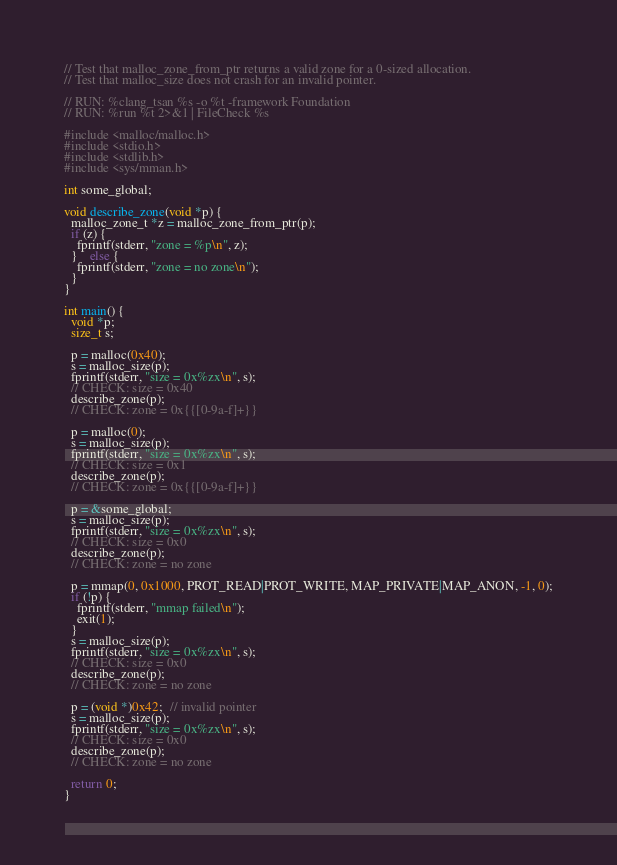<code> <loc_0><loc_0><loc_500><loc_500><_ObjectiveC_>// Test that malloc_zone_from_ptr returns a valid zone for a 0-sized allocation.
// Test that malloc_size does not crash for an invalid pointer.

// RUN: %clang_tsan %s -o %t -framework Foundation
// RUN: %run %t 2>&1 | FileCheck %s

#include <malloc/malloc.h>
#include <stdio.h>
#include <stdlib.h>
#include <sys/mman.h>

int some_global;

void describe_zone(void *p) {
  malloc_zone_t *z = malloc_zone_from_ptr(p);
  if (z) {
    fprintf(stderr, "zone = %p\n", z);
  }	else {
  	fprintf(stderr, "zone = no zone\n");
  }
}

int main() {
  void *p;
  size_t s;

  p = malloc(0x40);
  s = malloc_size(p);
  fprintf(stderr, "size = 0x%zx\n", s);
  // CHECK: size = 0x40
  describe_zone(p);
  // CHECK: zone = 0x{{[0-9a-f]+}}

  p = malloc(0);
  s = malloc_size(p);
  fprintf(stderr, "size = 0x%zx\n", s);
  // CHECK: size = 0x1
  describe_zone(p);
  // CHECK: zone = 0x{{[0-9a-f]+}}

  p = &some_global;
  s = malloc_size(p);
  fprintf(stderr, "size = 0x%zx\n", s);
  // CHECK: size = 0x0
  describe_zone(p);
  // CHECK: zone = no zone

  p = mmap(0, 0x1000, PROT_READ|PROT_WRITE, MAP_PRIVATE|MAP_ANON, -1, 0);
  if (!p) {
  	fprintf(stderr, "mmap failed\n");
  	exit(1);
  }
  s = malloc_size(p);
  fprintf(stderr, "size = 0x%zx\n", s);
  // CHECK: size = 0x0
  describe_zone(p);
  // CHECK: zone = no zone

  p = (void *)0x42;  // invalid pointer
  s = malloc_size(p);
  fprintf(stderr, "size = 0x%zx\n", s);
  // CHECK: size = 0x0
  describe_zone(p);
  // CHECK: zone = no zone

  return 0;
}
</code> 